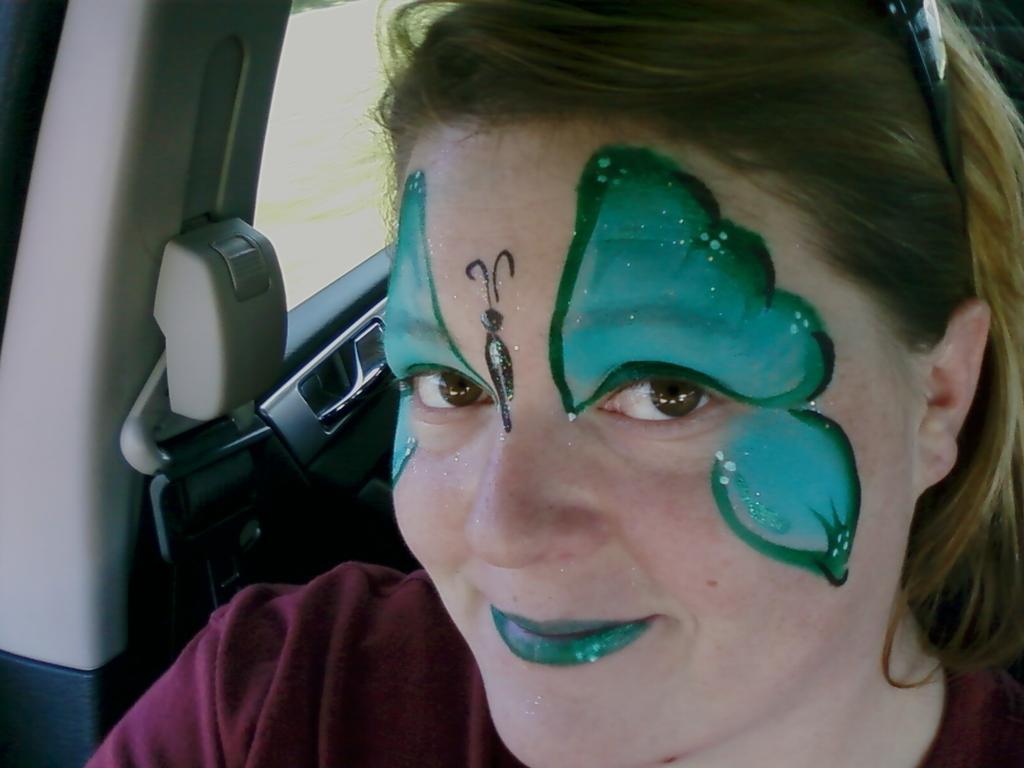Could you give a brief overview of what you see in this image? In this image there is a woman sitting in the vehicle. She has a painting on her face. Beside her there is a seat belt. 